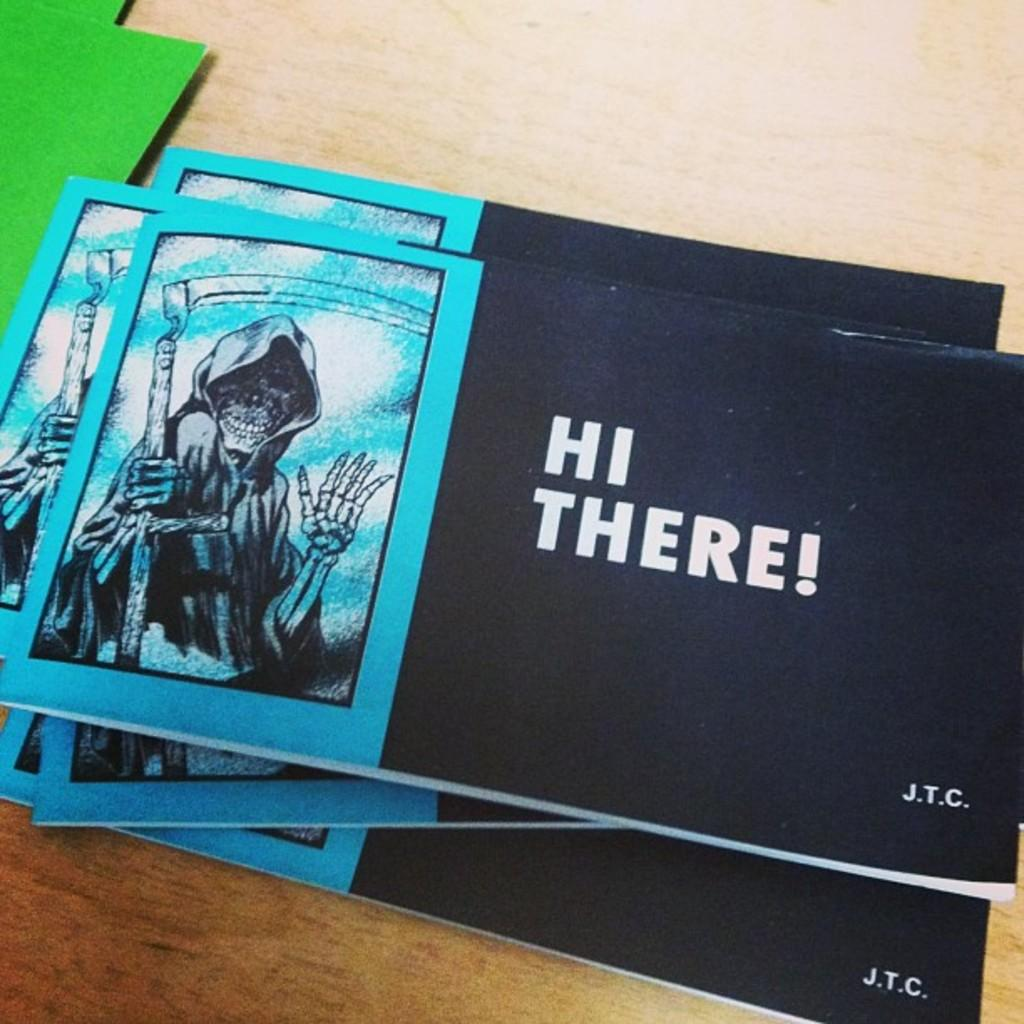<image>
Present a compact description of the photo's key features. Pamphlets with a skeleton on the cover have Hi There! written in text. 